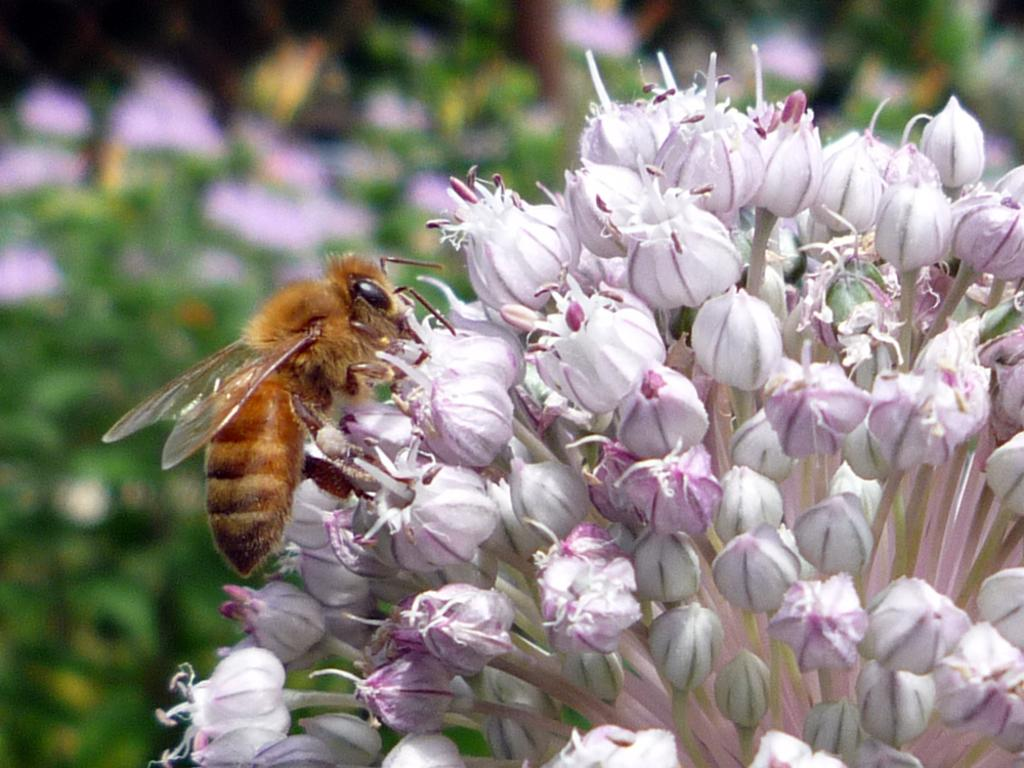What is on the flower in the image? There is an insect on a flower in the image. How many flowers can be seen in the image? There are present in the image? What can be observed about the background of the image? The background of the image is blurred. What type of meal is the insect preparing on the flower in the image? There is no indication in the image that the insect is preparing a meal or engaging in any activity other than being on the flower. 